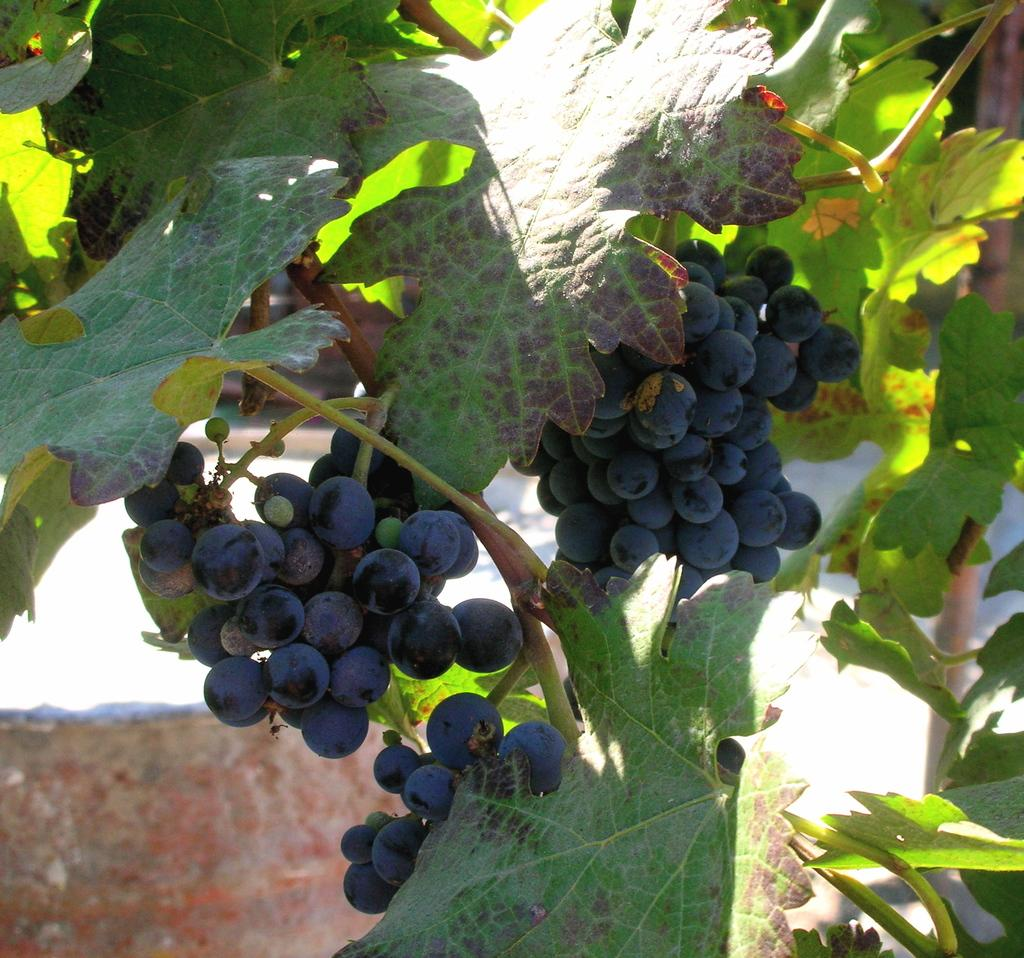What type of grapes can be seen in the image? There are black color grapes in the image. What other elements can be seen in the image besides the grapes? There are green leaves in the image. What can be seen in the background of the image? There is a wall visible in the background of the image. What type of advertisement is displayed on the wall in the image? There is no advertisement present on the wall in the image; it is just a plain wall visible in the background. 